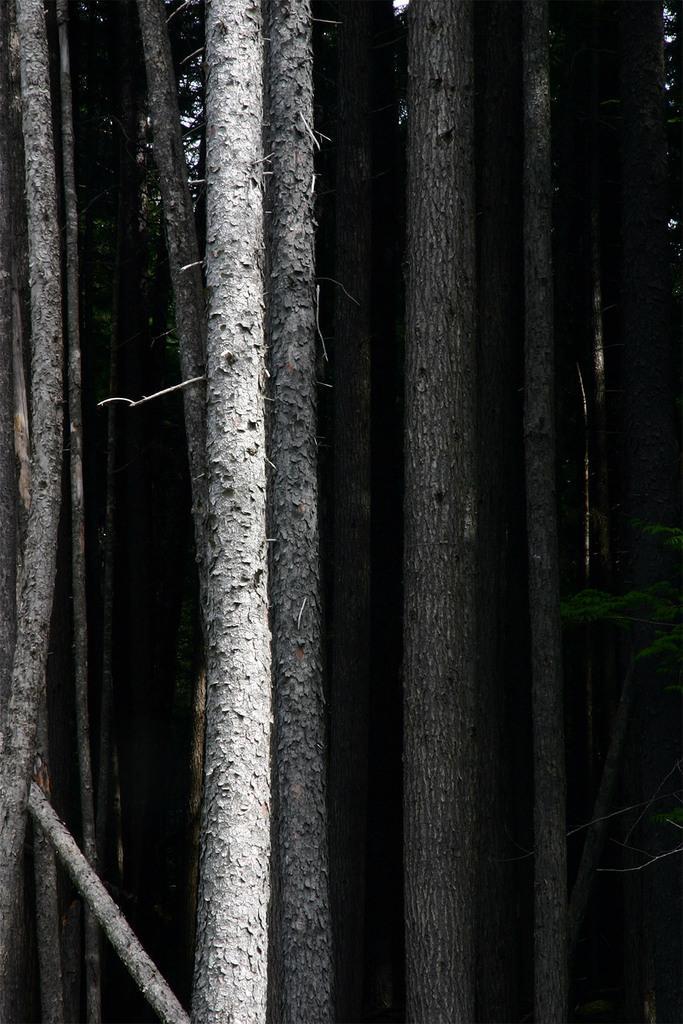Please provide a concise description of this image. In this picture there are trees. 